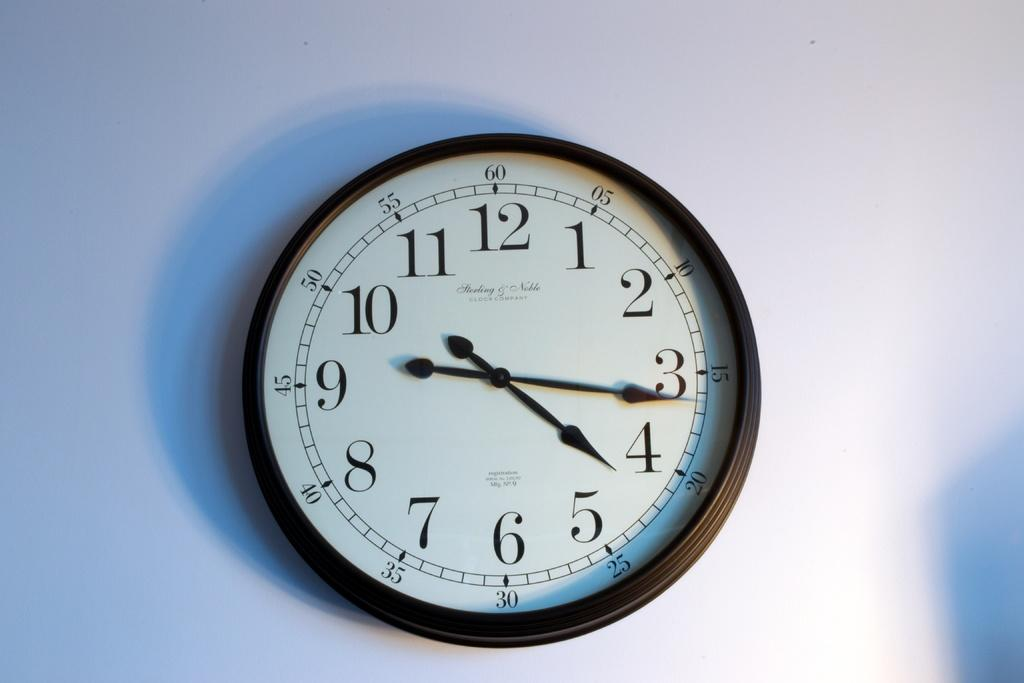<image>
Give a short and clear explanation of the subsequent image. A sterling and noble clock sits on a wal 